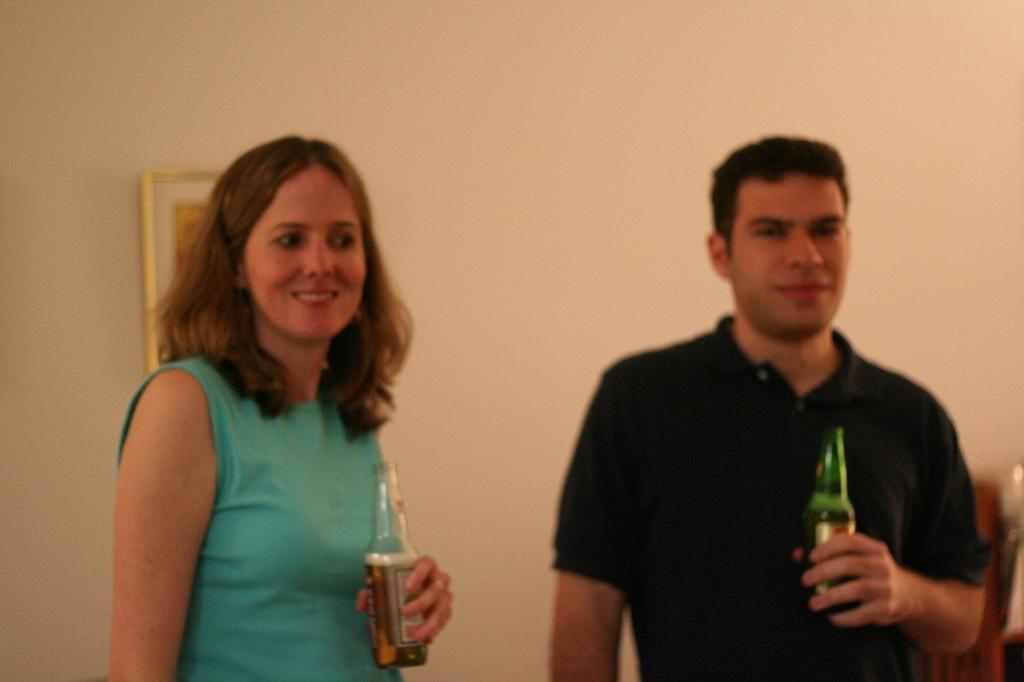How many people are in the image? There are two people in the image, a man and a woman. What are the man and the woman doing in the image? Both the man and the woman are standing and smiling. What are they holding in their hands? The man is holding a beer bottle, and the woman is also holding a beer bottle. What type of sweater is the woman wearing in the image? There is no sweater mentioned or visible in the image. What story is the man telling the woman in the image? There is no indication of a story being told in the image; both the man and the woman are simply standing and smiling. 